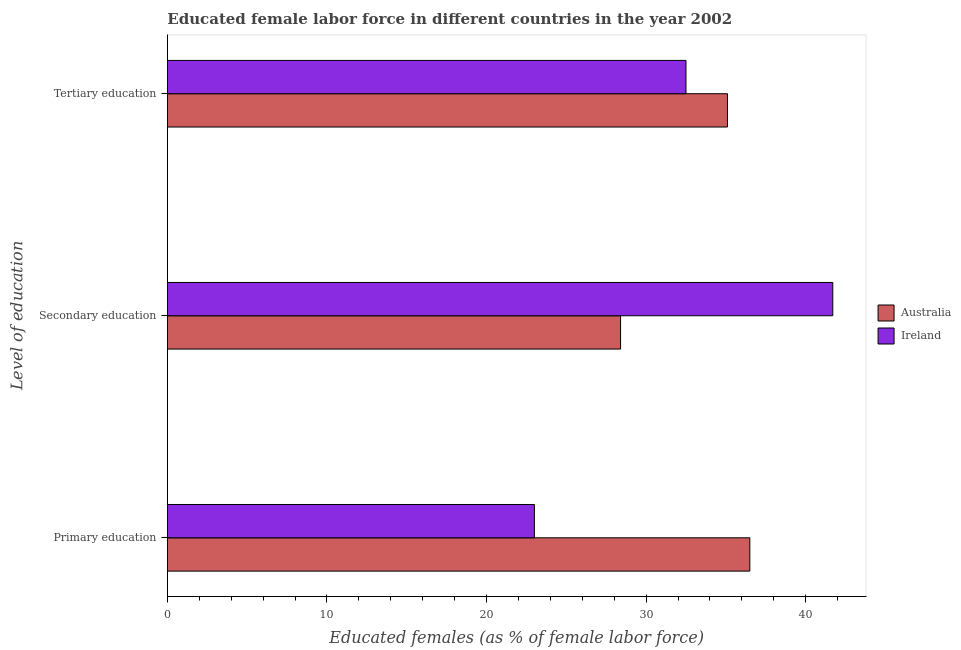How many different coloured bars are there?
Your answer should be very brief. 2. Are the number of bars per tick equal to the number of legend labels?
Your response must be concise. Yes. How many bars are there on the 1st tick from the bottom?
Provide a succinct answer. 2. What is the label of the 1st group of bars from the top?
Give a very brief answer. Tertiary education. What is the percentage of female labor force who received secondary education in Australia?
Your answer should be compact. 28.4. Across all countries, what is the maximum percentage of female labor force who received primary education?
Ensure brevity in your answer.  36.5. In which country was the percentage of female labor force who received tertiary education maximum?
Offer a terse response. Australia. In which country was the percentage of female labor force who received primary education minimum?
Your response must be concise. Ireland. What is the total percentage of female labor force who received tertiary education in the graph?
Offer a terse response. 67.6. What is the difference between the percentage of female labor force who received tertiary education in Ireland and that in Australia?
Keep it short and to the point. -2.6. What is the difference between the percentage of female labor force who received primary education in Ireland and the percentage of female labor force who received secondary education in Australia?
Your response must be concise. -5.4. What is the average percentage of female labor force who received secondary education per country?
Give a very brief answer. 35.05. What is the difference between the percentage of female labor force who received secondary education and percentage of female labor force who received tertiary education in Australia?
Ensure brevity in your answer.  -6.7. What is the ratio of the percentage of female labor force who received secondary education in Ireland to that in Australia?
Offer a very short reply. 1.47. What is the difference between the highest and the lowest percentage of female labor force who received secondary education?
Provide a short and direct response. 13.3. In how many countries, is the percentage of female labor force who received secondary education greater than the average percentage of female labor force who received secondary education taken over all countries?
Give a very brief answer. 1. Is it the case that in every country, the sum of the percentage of female labor force who received primary education and percentage of female labor force who received secondary education is greater than the percentage of female labor force who received tertiary education?
Make the answer very short. Yes. How many bars are there?
Make the answer very short. 6. How many countries are there in the graph?
Provide a succinct answer. 2. Are the values on the major ticks of X-axis written in scientific E-notation?
Your answer should be very brief. No. Does the graph contain grids?
Provide a short and direct response. No. Where does the legend appear in the graph?
Offer a very short reply. Center right. How are the legend labels stacked?
Keep it short and to the point. Vertical. What is the title of the graph?
Your answer should be compact. Educated female labor force in different countries in the year 2002. What is the label or title of the X-axis?
Your answer should be very brief. Educated females (as % of female labor force). What is the label or title of the Y-axis?
Your answer should be compact. Level of education. What is the Educated females (as % of female labor force) in Australia in Primary education?
Your answer should be compact. 36.5. What is the Educated females (as % of female labor force) in Ireland in Primary education?
Your answer should be very brief. 23. What is the Educated females (as % of female labor force) in Australia in Secondary education?
Your answer should be very brief. 28.4. What is the Educated females (as % of female labor force) of Ireland in Secondary education?
Your answer should be compact. 41.7. What is the Educated females (as % of female labor force) in Australia in Tertiary education?
Your response must be concise. 35.1. What is the Educated females (as % of female labor force) of Ireland in Tertiary education?
Keep it short and to the point. 32.5. Across all Level of education, what is the maximum Educated females (as % of female labor force) of Australia?
Ensure brevity in your answer.  36.5. Across all Level of education, what is the maximum Educated females (as % of female labor force) in Ireland?
Your answer should be compact. 41.7. Across all Level of education, what is the minimum Educated females (as % of female labor force) of Australia?
Provide a succinct answer. 28.4. What is the total Educated females (as % of female labor force) in Australia in the graph?
Provide a short and direct response. 100. What is the total Educated females (as % of female labor force) of Ireland in the graph?
Provide a succinct answer. 97.2. What is the difference between the Educated females (as % of female labor force) in Ireland in Primary education and that in Secondary education?
Make the answer very short. -18.7. What is the difference between the Educated females (as % of female labor force) in Ireland in Primary education and that in Tertiary education?
Your answer should be compact. -9.5. What is the difference between the Educated females (as % of female labor force) in Ireland in Secondary education and that in Tertiary education?
Ensure brevity in your answer.  9.2. What is the difference between the Educated females (as % of female labor force) in Australia in Primary education and the Educated females (as % of female labor force) in Ireland in Secondary education?
Make the answer very short. -5.2. What is the difference between the Educated females (as % of female labor force) of Australia in Primary education and the Educated females (as % of female labor force) of Ireland in Tertiary education?
Offer a terse response. 4. What is the difference between the Educated females (as % of female labor force) of Australia in Secondary education and the Educated females (as % of female labor force) of Ireland in Tertiary education?
Your response must be concise. -4.1. What is the average Educated females (as % of female labor force) of Australia per Level of education?
Your answer should be very brief. 33.33. What is the average Educated females (as % of female labor force) in Ireland per Level of education?
Offer a very short reply. 32.4. What is the difference between the Educated females (as % of female labor force) of Australia and Educated females (as % of female labor force) of Ireland in Tertiary education?
Your answer should be compact. 2.6. What is the ratio of the Educated females (as % of female labor force) of Australia in Primary education to that in Secondary education?
Give a very brief answer. 1.29. What is the ratio of the Educated females (as % of female labor force) in Ireland in Primary education to that in Secondary education?
Provide a succinct answer. 0.55. What is the ratio of the Educated females (as % of female labor force) in Australia in Primary education to that in Tertiary education?
Make the answer very short. 1.04. What is the ratio of the Educated females (as % of female labor force) of Ireland in Primary education to that in Tertiary education?
Your answer should be compact. 0.71. What is the ratio of the Educated females (as % of female labor force) of Australia in Secondary education to that in Tertiary education?
Provide a short and direct response. 0.81. What is the ratio of the Educated females (as % of female labor force) of Ireland in Secondary education to that in Tertiary education?
Your response must be concise. 1.28. What is the difference between the highest and the lowest Educated females (as % of female labor force) of Ireland?
Give a very brief answer. 18.7. 